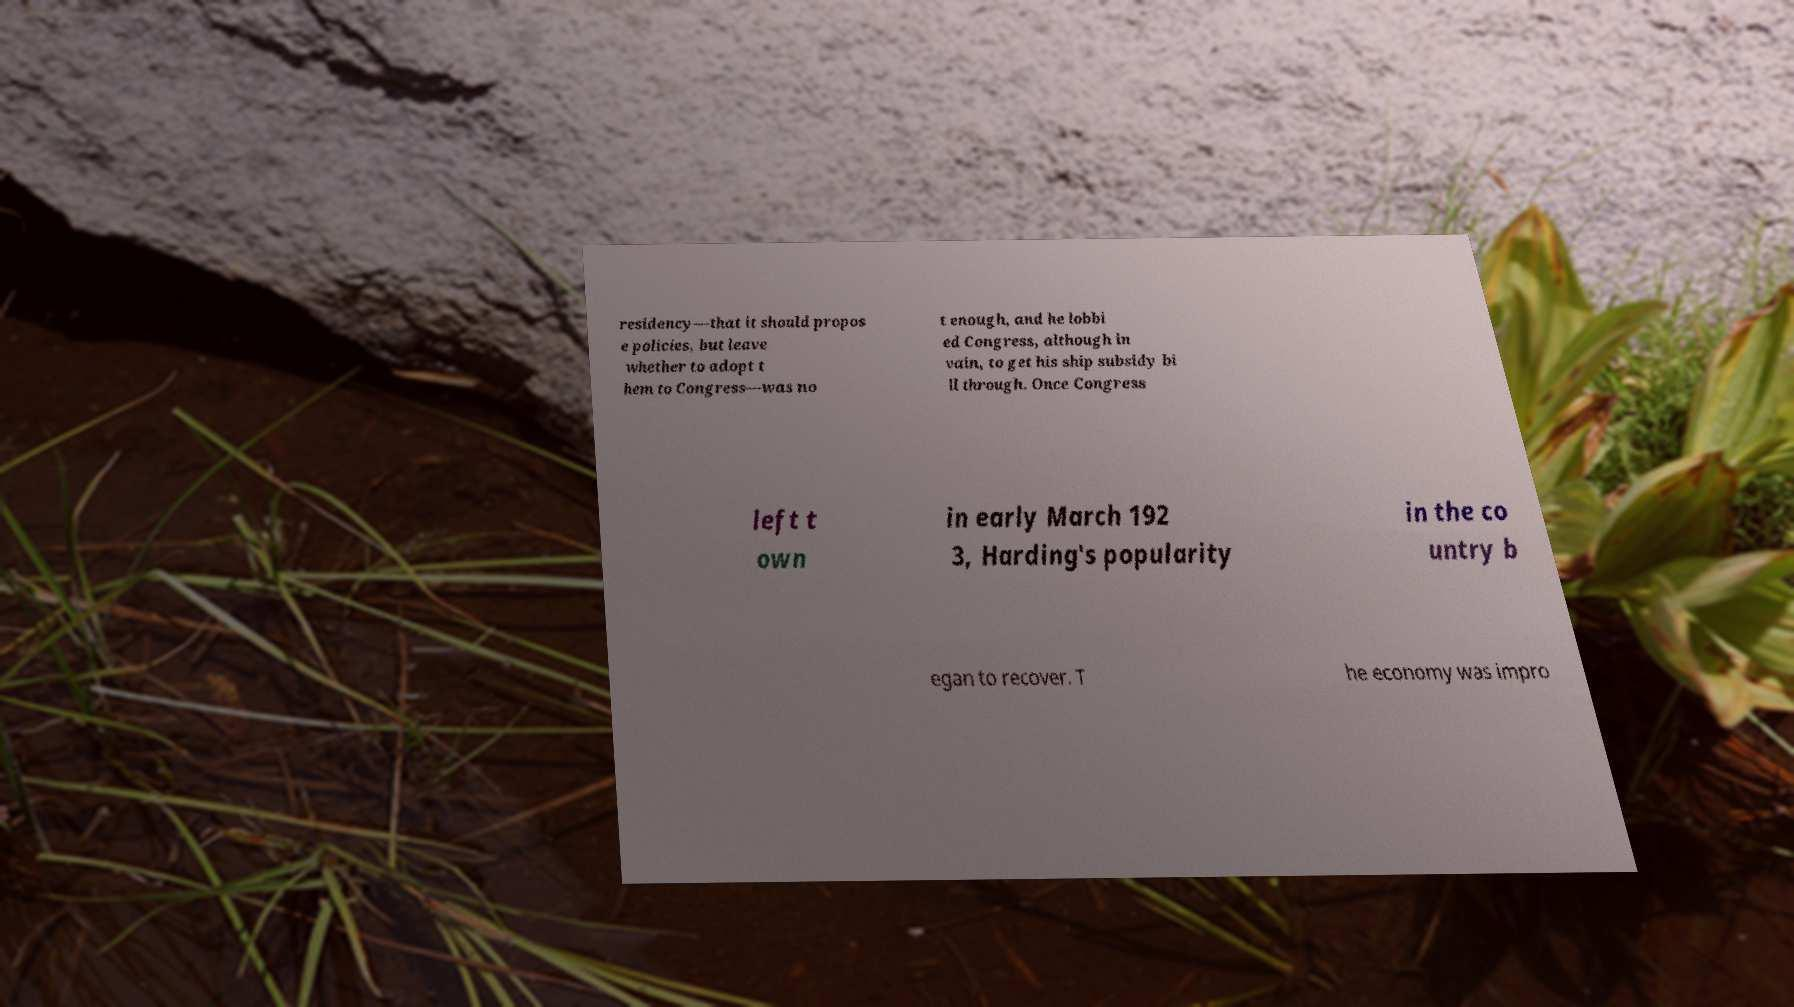Could you extract and type out the text from this image? residency—that it should propos e policies, but leave whether to adopt t hem to Congress—was no t enough, and he lobbi ed Congress, although in vain, to get his ship subsidy bi ll through. Once Congress left t own in early March 192 3, Harding's popularity in the co untry b egan to recover. T he economy was impro 